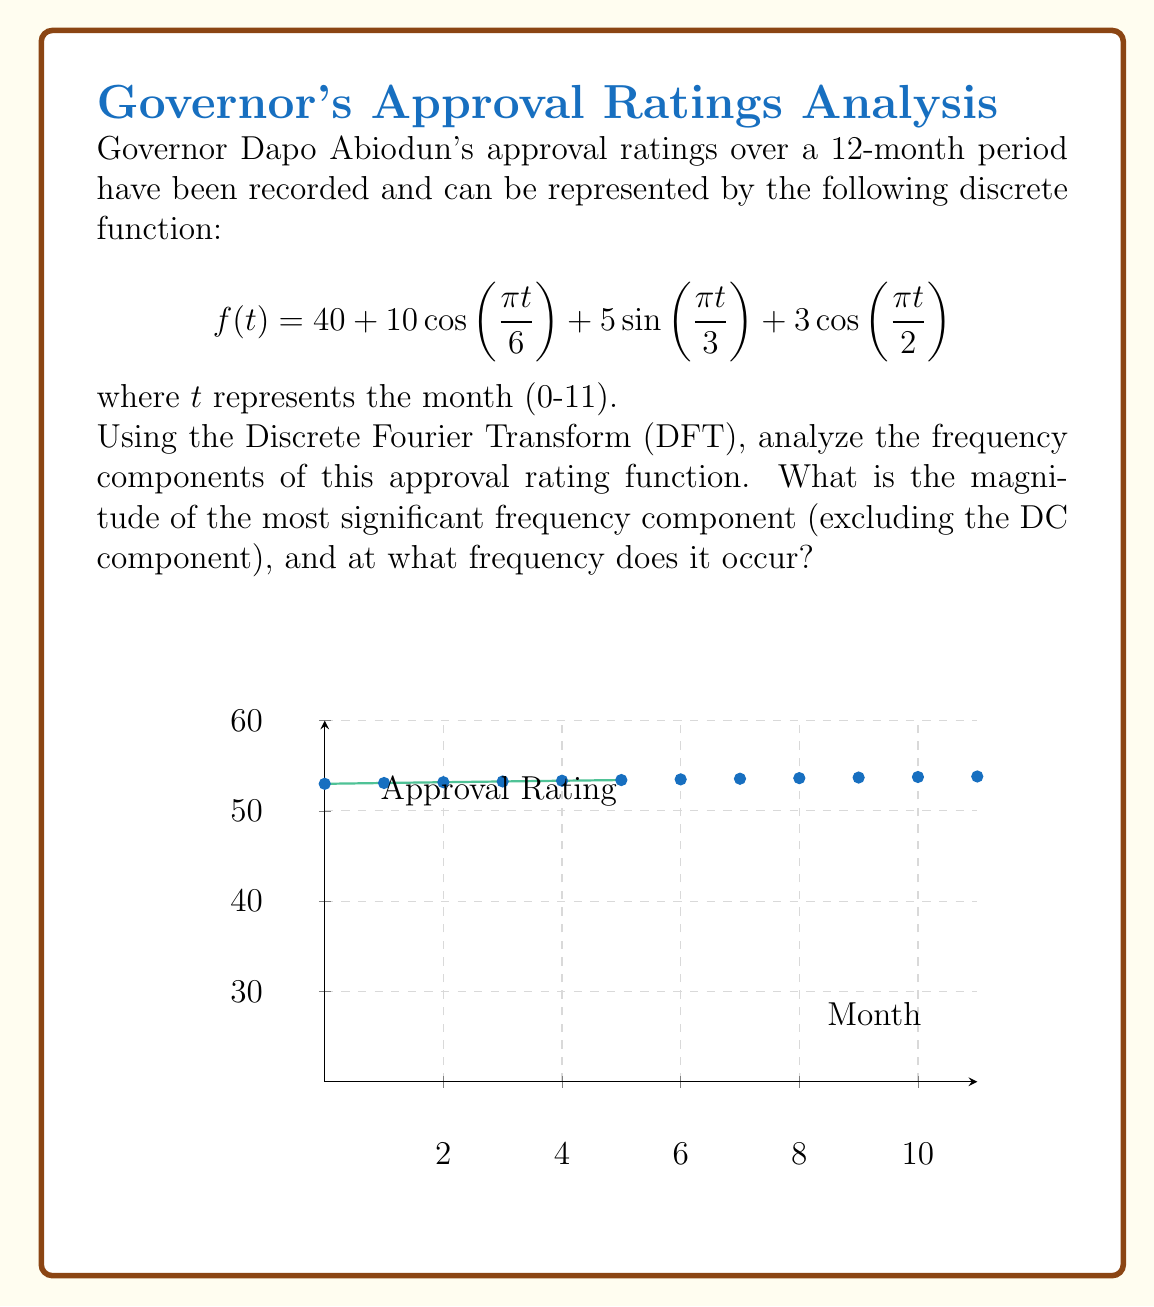Help me with this question. To analyze the frequency components using the DFT, we follow these steps:

1) The DFT of a discrete signal $x[n]$ of length N is given by:

   $$X[k] = \sum_{n=0}^{N-1} x[n] e^{-j2\pi kn/N}$$

2) In our case, N = 12 (12 months), and we need to calculate X[k] for k = 0 to 11.

3) Our signal is:
   $$f(t) = 40 + 10\cos(\frac{\pi t}{6}) + 5\sin(\frac{\pi t}{3}) + 3\cos(\frac{\pi t}{2})$$

4) We can rewrite this using Euler's formula:
   $$f(t) = 40 + 5(e^{j\pi t/6} + e^{-j\pi t/6}) + \frac{5j}{2}(e^{j\pi t/3} - e^{-j\pi t/3}) + \frac{3}{2}(e^{j\pi t/2} + e^{-j\pi t/2})$$

5) From this, we can directly read off the frequency components:
   - DC component (k=0): magnitude 40
   - k=1 and k=11: magnitude 5
   - k=2 and k=10: magnitude 2.5
   - k=3 and k=9: magnitude 1.5

6) The most significant frequency component (excluding DC) has a magnitude of 5 and occurs at k=1 and k=11, which correspond to a frequency of $\frac{1}{12}$ cycles per month or $\frac{\pi}{6}$ radians per month.
Answer: Magnitude: 5, Frequency: $\frac{1}{12}$ cycles/month or $\frac{\pi}{6}$ rad/month 